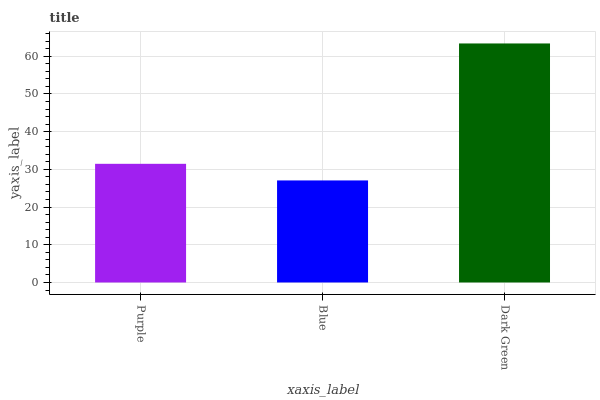Is Blue the minimum?
Answer yes or no. Yes. Is Dark Green the maximum?
Answer yes or no. Yes. Is Dark Green the minimum?
Answer yes or no. No. Is Blue the maximum?
Answer yes or no. No. Is Dark Green greater than Blue?
Answer yes or no. Yes. Is Blue less than Dark Green?
Answer yes or no. Yes. Is Blue greater than Dark Green?
Answer yes or no. No. Is Dark Green less than Blue?
Answer yes or no. No. Is Purple the high median?
Answer yes or no. Yes. Is Purple the low median?
Answer yes or no. Yes. Is Blue the high median?
Answer yes or no. No. Is Blue the low median?
Answer yes or no. No. 